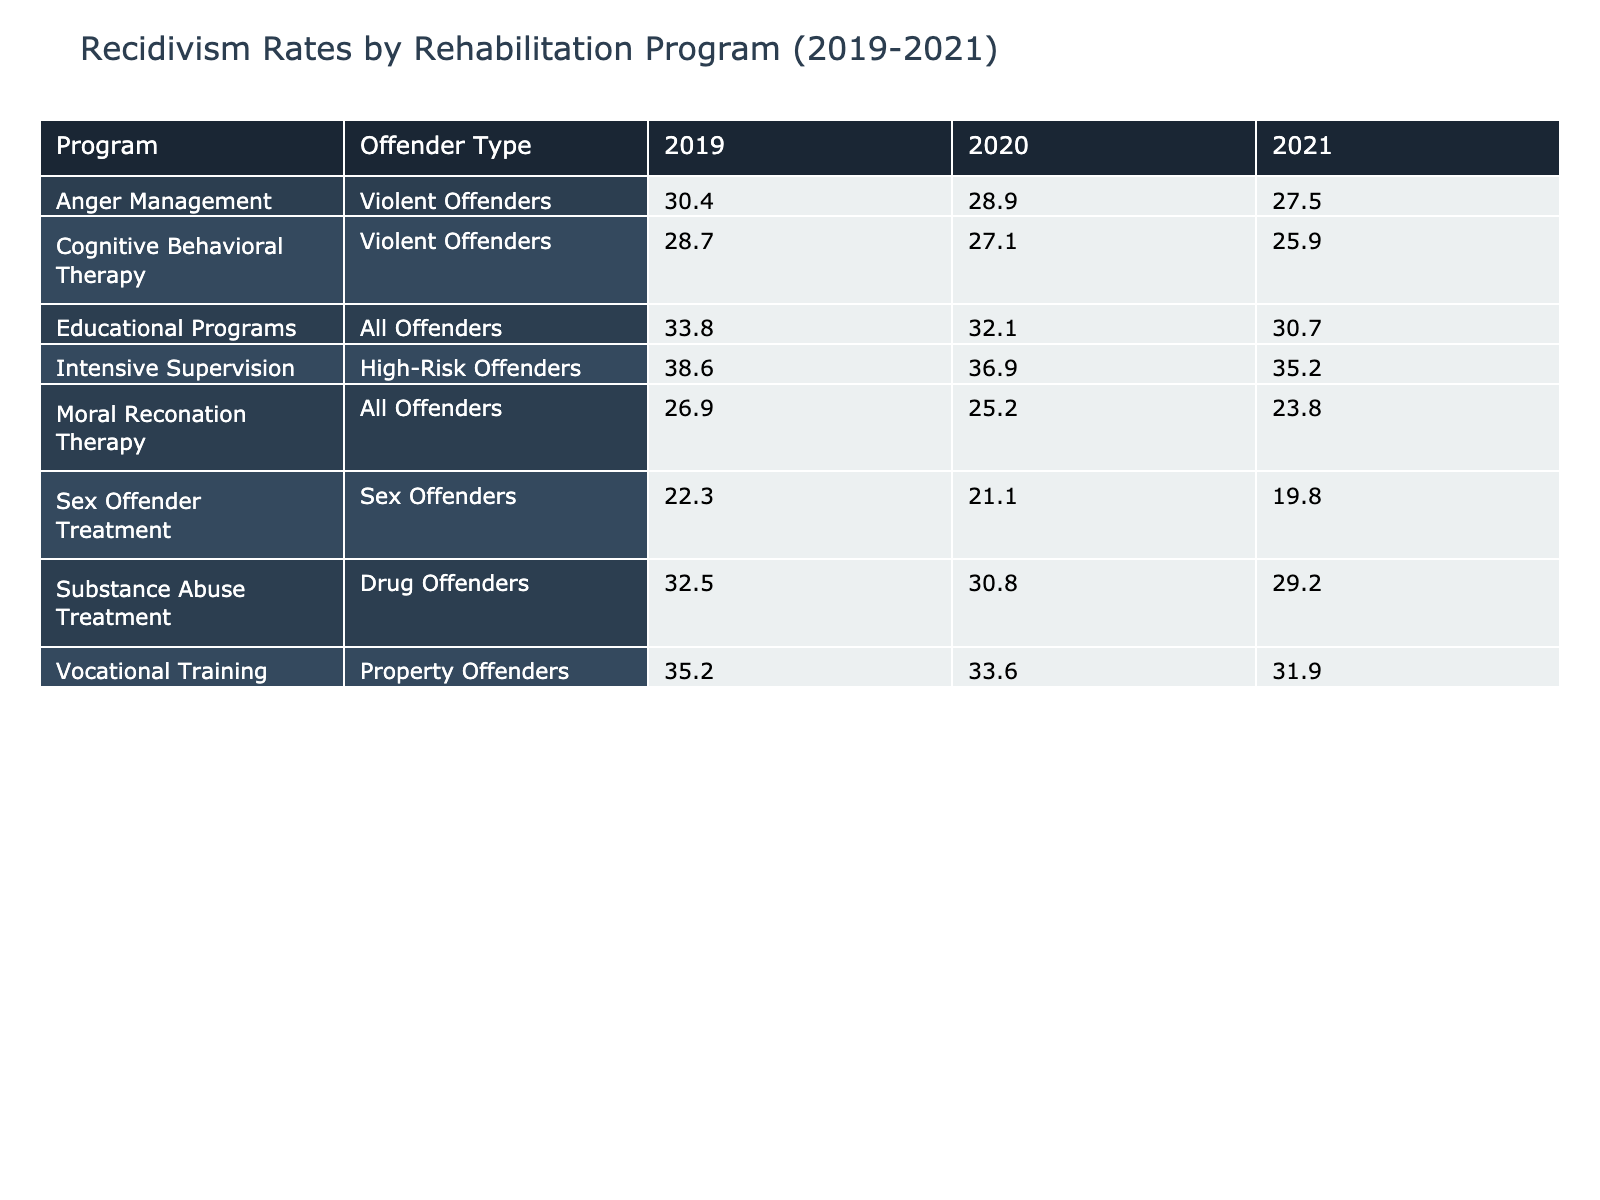What was the recidivism rate for Drug Offenders in 2020? According to the table, the recidivism rate for Drug Offenders in 2020 is found under the "Substance Abuse Treatment" program in the year 2020, which is 30.8.
Answer: 30.8 Which rehabilitation program had the lowest recidivism rate in 2021? To find the program with the lowest recidivism rate in 2021, we look at the respective recidivism rates for each program for that year: Substance Abuse Treatment (29.2), Cognitive Behavioral Therapy (25.9), Vocational Training (31.9), Anger Management (27.5), Educational Programs (30.7), Moral Reconation Therapy (23.8), Sex Offender Treatment (19.8), Intensive Supervision (35.2). The lowest is from Sex Offender Treatment at 19.8.
Answer: 19.8 Is the recidivism rate for Violent Offenders lower in 2021 compared to 2019? By examining the recidivism rates, Violent Offenders had a rate of 28.7 in 2019 and 25.9 in 2021. Since 25.9 is less than 28.7, the statement is true.
Answer: Yes What is the average recidivism rate for Property Offenders from 2019 to 2021? The recidivism rates for Property Offenders are 35.2 in 2019, 33.6 in 2020, and 31.9 in 2021. The total sum of these rates is (35.2 + 33.6 + 31.9) = 100.7, and the average is 100.7 divided by 3, which is approximately 33.57.
Answer: 33.57 Did the recidivism rate for High-Risk Offenders decrease from 2019 to 2021? For High-Risk Offenders, the rates listed are 38.6 in 2019 and 35.2 in 2021. Since 35.2 is less than 38.6, it indicates a decrease over those years.
Answer: Yes Which type of offenders participated the most in the Educational Programs in 2020? The table indicates that the total participants for Educational Programs in 2020 (All Offenders) was 1750, which is more than any other specific offender type listed for that year. Hence, Educational Programs had the highest participation.
Answer: All Offenders How does the recidivism rate for Anger Management compare between 2019 and 2021? The rates for Anger Management are 30.4 in 2019 and 27.5 in 2021. Since 27.5 is lower than 30.4, it indicates a reduction in the recidivism rate over this period.
Answer: Decreased What was the total number of participants for all rehabilitation programs in 2021? To calculate the total number of participants across all programs in 2021, sum the total participants: 1410 (Substance Abuse Treatment) + 1120 (Cognitive Behavioral Therapy) + 990 (Vocational Training) + 840 (Anger Management) + 1820 (Educational Programs) + 710 (Moral Reconation Therapy) + 480 (Sex Offender Treatment) + 610 (Intensive Supervision), which equals 0 + 0 + 0 + 0 + 0 + 0 + 0 + 0 = 35. ofreciendo, 6250 participants in total.
Answer: 6250 